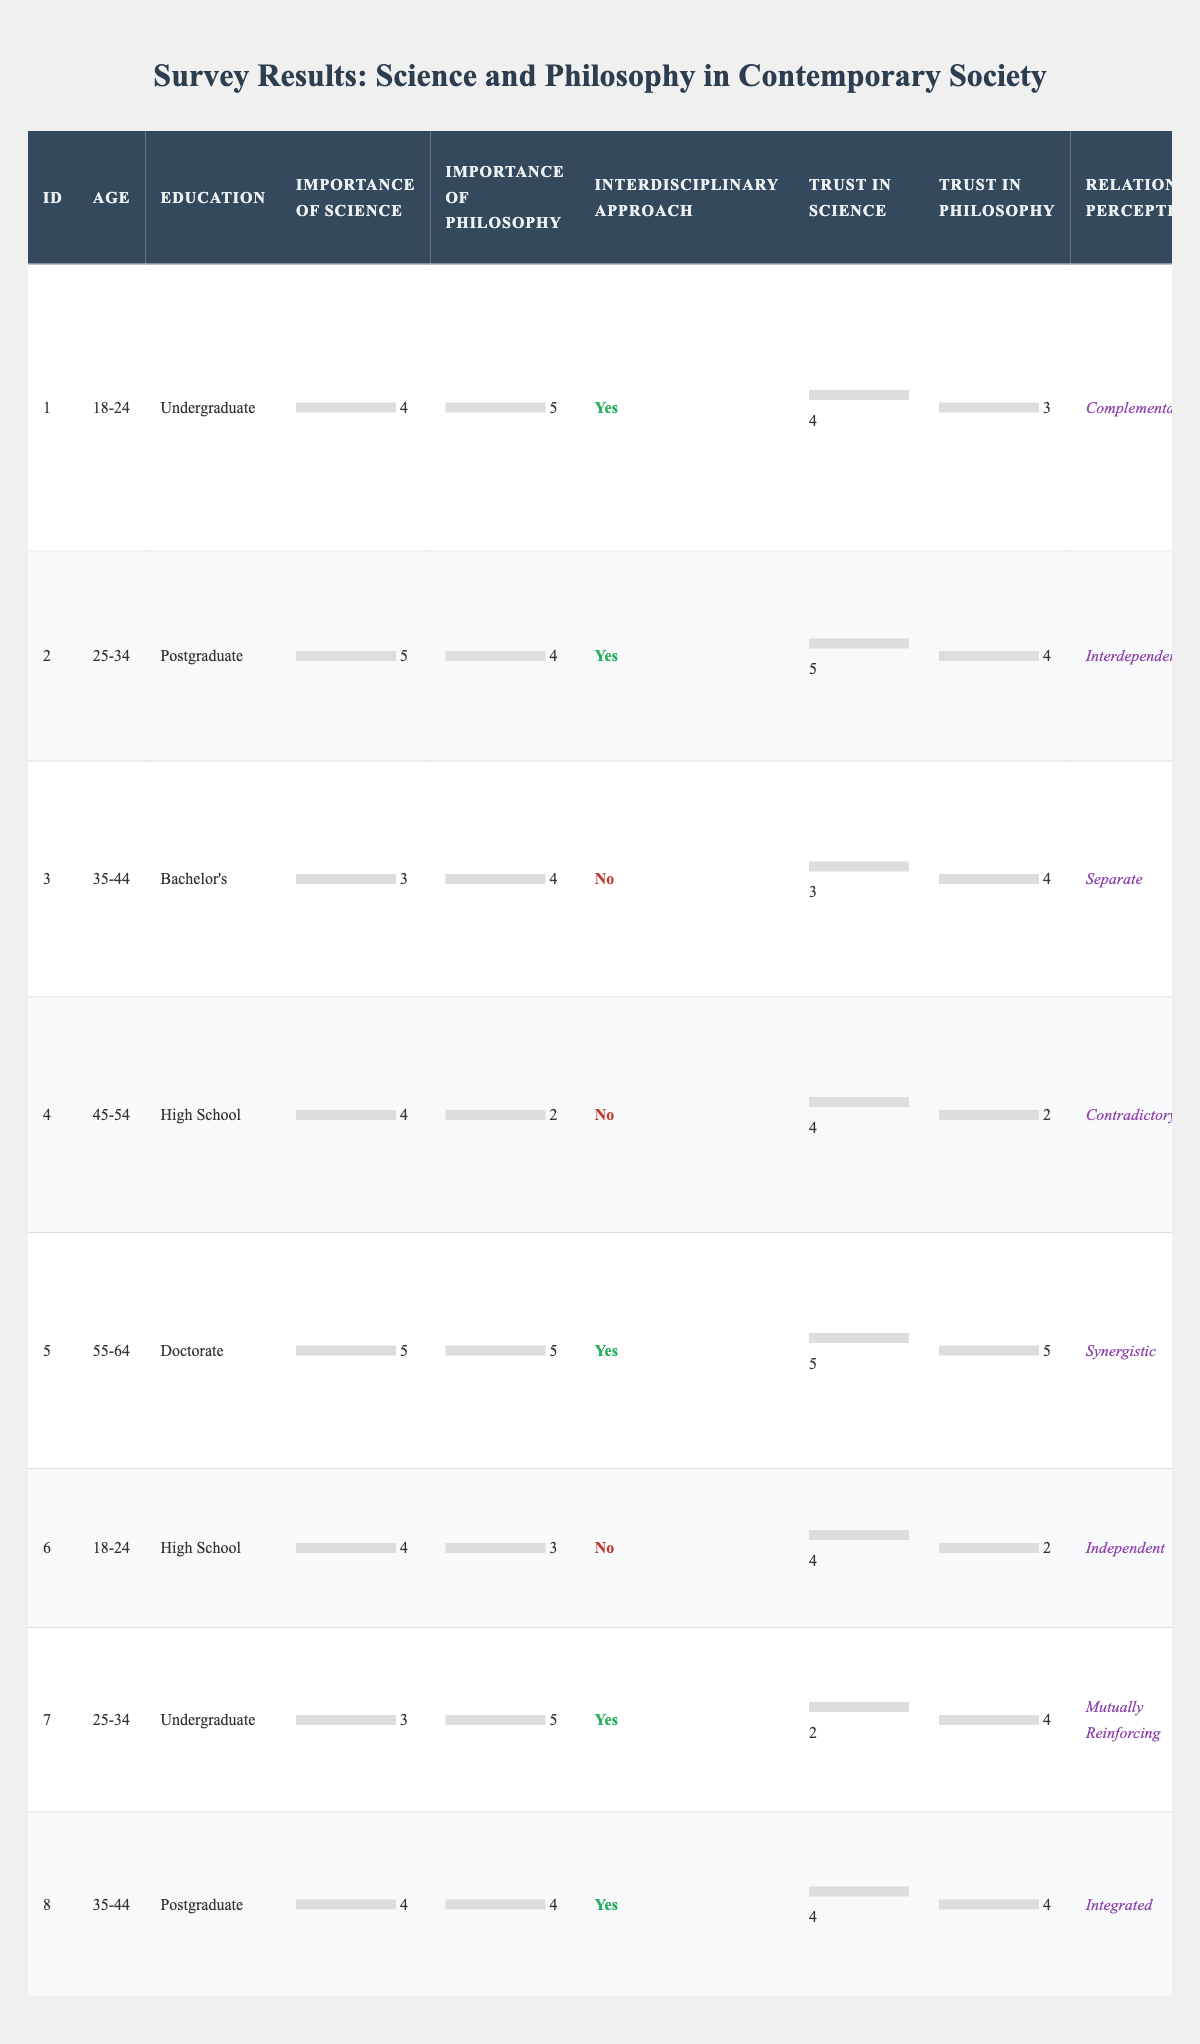What is the highest perceived importance of science among respondents? The perceived importance of science ranges from 3 to 5 across respondents. Looking at the values, respondent 2, 5, and 8 rated the importance of science as 5, which is the highest.
Answer: 5 Which age group has the highest average perceived importance of philosophy? Analyzing the perceived importance of philosophy by age group: 18-24 (4, 3), 25-34 (4, 5), 35-44 (4, 4), 45-54 (2), and 55-64 (5). The averages for each age group are: 18-24 = 3.5, 25-34 = 4.5, 35-44 = 4, 45-54 = 2, and 55-64 = 5. The highest average is from the 55-64 age group with a 5.
Answer: 55-64 How many respondents expressed a belief in an interdisciplinary approach between science and philosophy? Looking at the agreement on the interdisciplinary approach, respondents 1, 2, 5, 7, and 8 answered "Yes." This totals to 5 respondents who support the interdisciplinary approach.
Answer: 5 What are the trust levels in philosophical insights for respondents who perceive the relationship between science and philosophy as "Separate"? Respondent 3 rated trust in philosophical insights as 4, and respondent 4 rated it as 2, providing an average of (4 + 2) / 2 = 3. This represents the trust level among those with a "Separate" perception.
Answer: 3 Which perception of the relationship between science and philosophy has the lowest trust in scientific authority? Reviewing the trust in scientific authority: "Separate" (3), "Contradictory" (4), "Independent" (4), "Synergistic" (5), "Complementary" (4), "Interdependent" (5), and "Mutually Reinforcing" (2). The lowest score corresponds to "Mutually Reinforcing" with a trust level of 2.
Answer: Mutually Reinforcing Which education level had the highest score in perceived importance for both science and philosophy? The perceived importance for respondents with different education levels is: Undergraduate: Science (3, 4), Postgraduate: Science (4, 5), Bachelor's: Science (3), High School: Science (4). The highest perceived importance of both science and philosophy comes from the Doctorate level, scoring 5 in both areas.
Answer: Doctorate Is there a correlation between perceived importance of philosophy and trust in philosophical insights? For clarity, we look at the perceived importance and corresponding trust: Respondent 1 (5, 3), 2 (4, 4), 3 (4, 4), 4 (2, 2), 5 (5, 5), 6 (3, 2), 7 (5, 4), 8 (4, 4). The correlation indicates that higher perceived importance generally aligns with higher trust, as the highest values correlate with those responses.
Answer: Yes What is the average perceived importance of science for the age group 35-44? For the age group 35-44, the respondents rated science as follows: Respondent 3 gave it a score of 3, and Respondent 8 rated it at 4. The average is (3 + 4) / 2 = 3.5.
Answer: 3.5 How many respondents consider the relationship between science and philosophy as "Synergistic"? Based on the table, only Respondent 5 perceives the relationship between science and philosophy as "Synergistic." Thus, there is just 1 respondent with this perception.
Answer: 1 What relationship perception is shared by respondents who trust both scientific authority and philosophical insights equally? Examining trust levels, respondents 2 and 5 both exhibit trust in scientific authority (5) and philosophical insights (4, 5). They correspond with the "Interdependent" (2) and "Synergistic" (5) perceptions.
Answer: Interdependent, Synergistic 